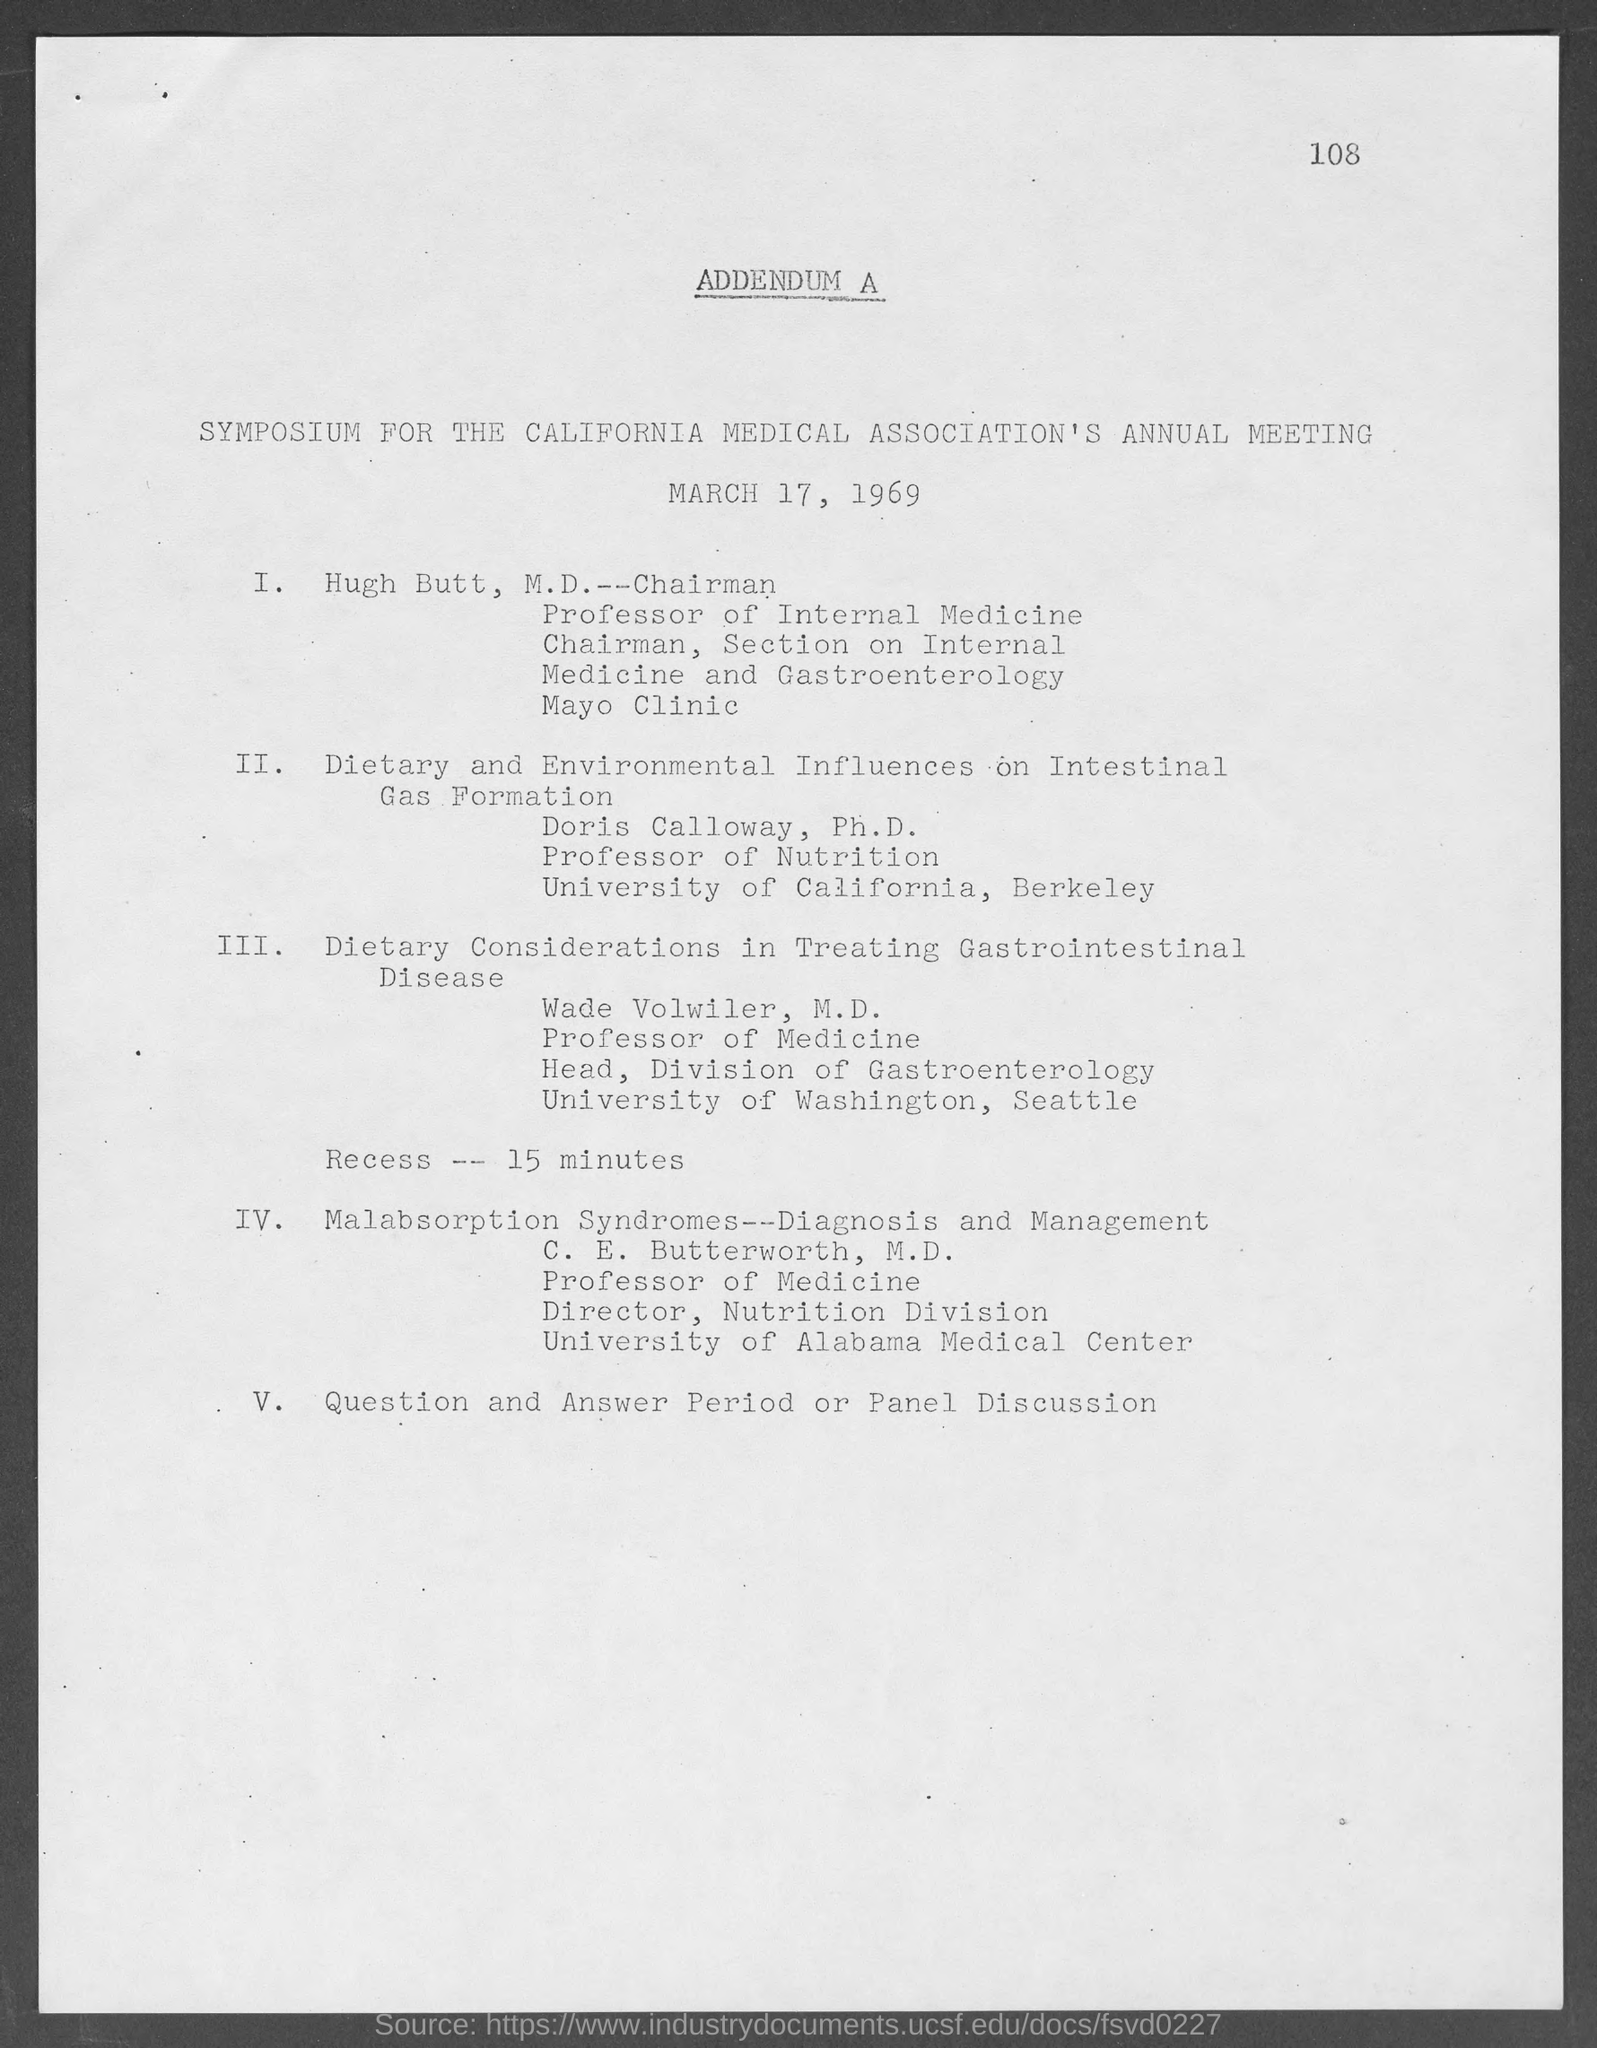What is the date mentioned in the given page ?
Provide a succinct answer. March 17, 1969. 